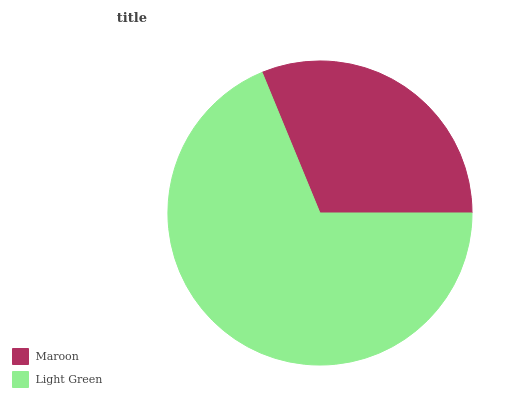Is Maroon the minimum?
Answer yes or no. Yes. Is Light Green the maximum?
Answer yes or no. Yes. Is Light Green the minimum?
Answer yes or no. No. Is Light Green greater than Maroon?
Answer yes or no. Yes. Is Maroon less than Light Green?
Answer yes or no. Yes. Is Maroon greater than Light Green?
Answer yes or no. No. Is Light Green less than Maroon?
Answer yes or no. No. Is Light Green the high median?
Answer yes or no. Yes. Is Maroon the low median?
Answer yes or no. Yes. Is Maroon the high median?
Answer yes or no. No. Is Light Green the low median?
Answer yes or no. No. 